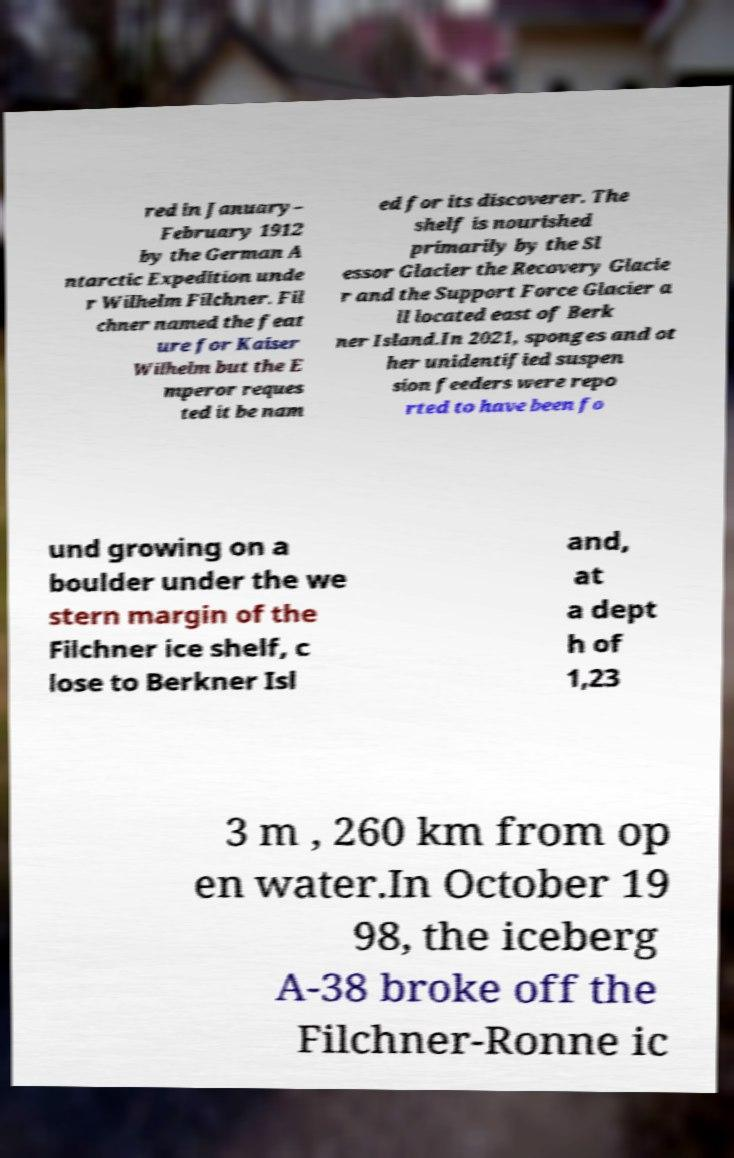Can you accurately transcribe the text from the provided image for me? red in January– February 1912 by the German A ntarctic Expedition unde r Wilhelm Filchner. Fil chner named the feat ure for Kaiser Wilhelm but the E mperor reques ted it be nam ed for its discoverer. The shelf is nourished primarily by the Sl essor Glacier the Recovery Glacie r and the Support Force Glacier a ll located east of Berk ner Island.In 2021, sponges and ot her unidentified suspen sion feeders were repo rted to have been fo und growing on a boulder under the we stern margin of the Filchner ice shelf, c lose to Berkner Isl and, at a dept h of 1,23 3 m , 260 km from op en water.In October 19 98, the iceberg A-38 broke off the Filchner-Ronne ic 